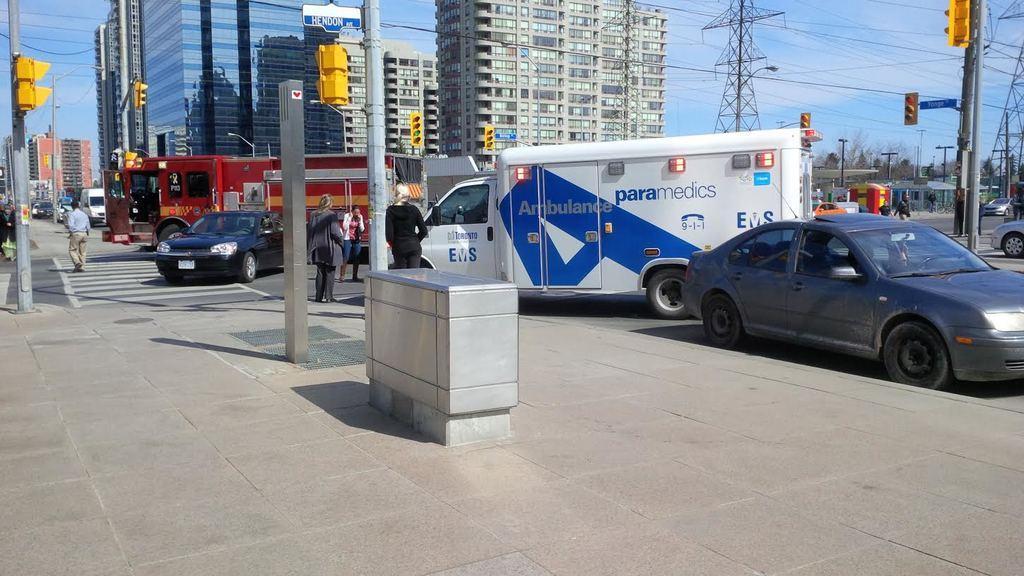Please provide a concise description of this image. In this image I can see a road , in the road I can see buses and persons and I can see a divider and in the divider I can see poles and at the top I can see building ,tower and power line cables and persons walking on the road. On the left side I can see a person walking on zebra cross line and buildings and vehicles and poles and power line cables. 